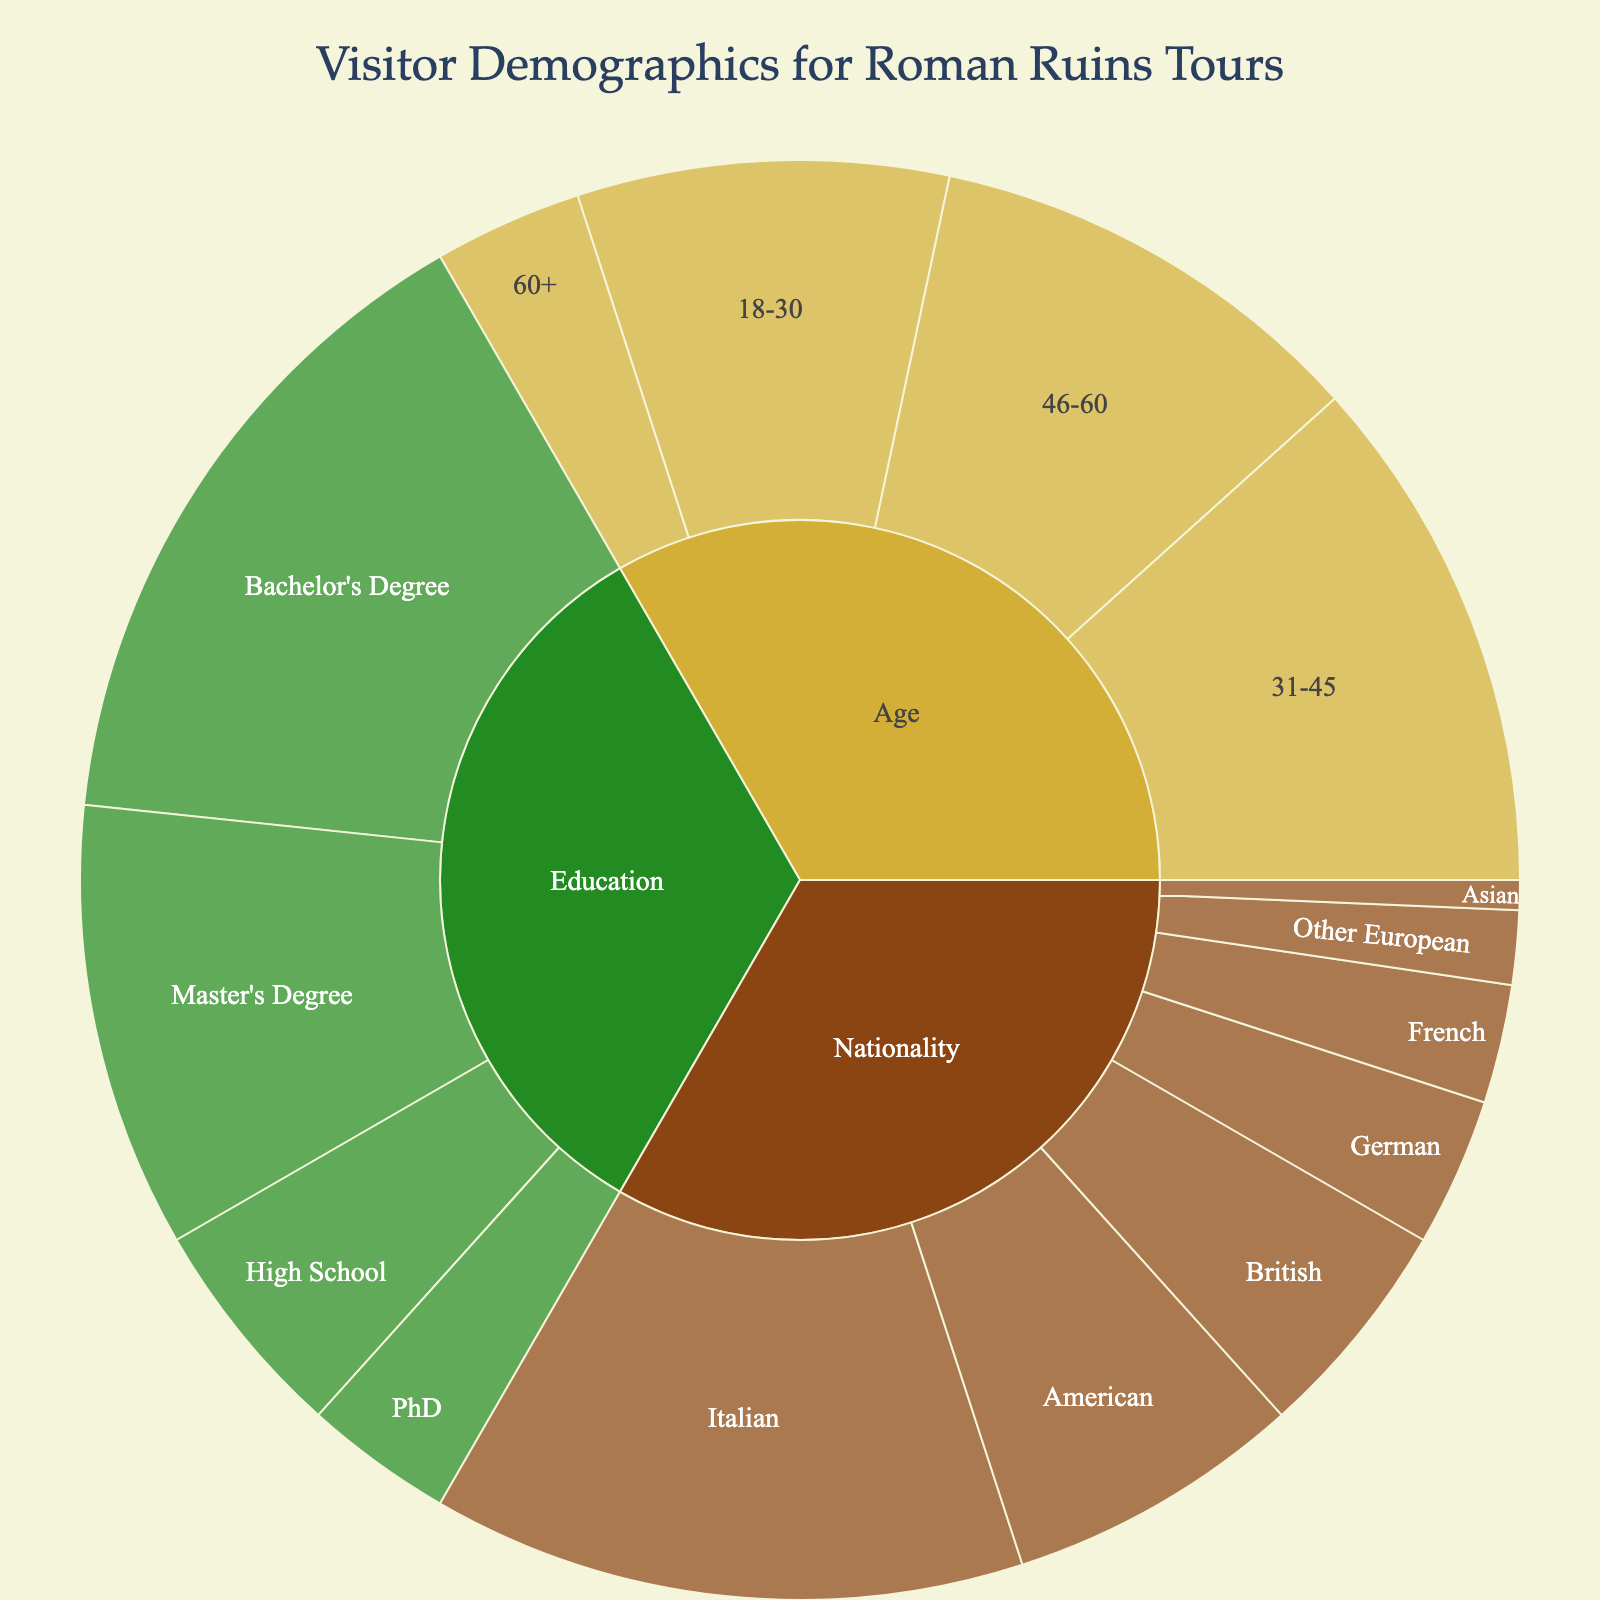What is the title of the sunburst plot? The title is prominently displayed at the top of the sunburst plot. From the provided code, it is "Visitor Demographics for Roman Ruins Tours".
Answer: Visitor Demographics for Roman Ruins Tours Which age group has the highest percentage of visitors? By examining the relative sizes of the sections within the "Age" category, the "31-45" age group is the largest, followed by "18-30", "46-60", and "60+" respectively.
Answer: 31-45 What is the combined percentage of visitors with a Bachelor's or Master's Degree? Add the individual percentages for "Bachelor's Degree" (45%) and "Master's Degree" (30%) within the "Education" category. The sum is 45 + 30 = 75%.
Answer: 75% Which nationality makes up the smallest percentage of visitors? Within the "Nationality" category, the "Asian" section has the smallest relative size, indicating it has the lowest percentage.
Answer: Asian How does the percentage of visitors aged 18-30 compare to those aged 46-60? The sections for "18-30" and "46-60" age groups are identified within the "Age" category as 25% and 30% respectively. Comparing them, 25% < 30%.
Answer: 18-30 has a lower percentage than 46-60 Is the percentage of Italian visitors greater than the sum of British and German visitors? The percentage of Italian visitors is 40%. The percentages for British and German visitors are 15% and 10% respectively. Sum them to get 15 + 10 = 25%. Since 40% > 25%, the answer is yes.
Answer: Yes What is the total percentage of visitors from non-Italian European nationalities? Non-Italian European nationalities include British (15%), German (10%), French (8%), and Other European (5%). Sum them: 15 + 10 + 8 + 5 = 38%.
Answer: 38% Does the PhD group make up more or less than 1/5 of the Bachelor's Degree group? The PhD group is 10%, and 1/5 (or 20%) of the Bachelor's Degree group is 45/5 = 9%. Since 10% > 9%, the answer is more.
Answer: More What percentage of visitors are aged 31 and above? This includes the age groups "31-45" (35%), "46-60" (30%), and "60+" (10%). Sum them: 35 + 30 + 10 = 75%.
Answer: 75% Which category (Age, Nationality or Education) has the highest single subcategory percentage? Examining the highest single percentages within each category: Age (31-45 is 35%), Nationality (Italian is 40%), Education (Bachelor's Degree is 45%). The highest among these is Bachelor's Degree at 45%.
Answer: Education 